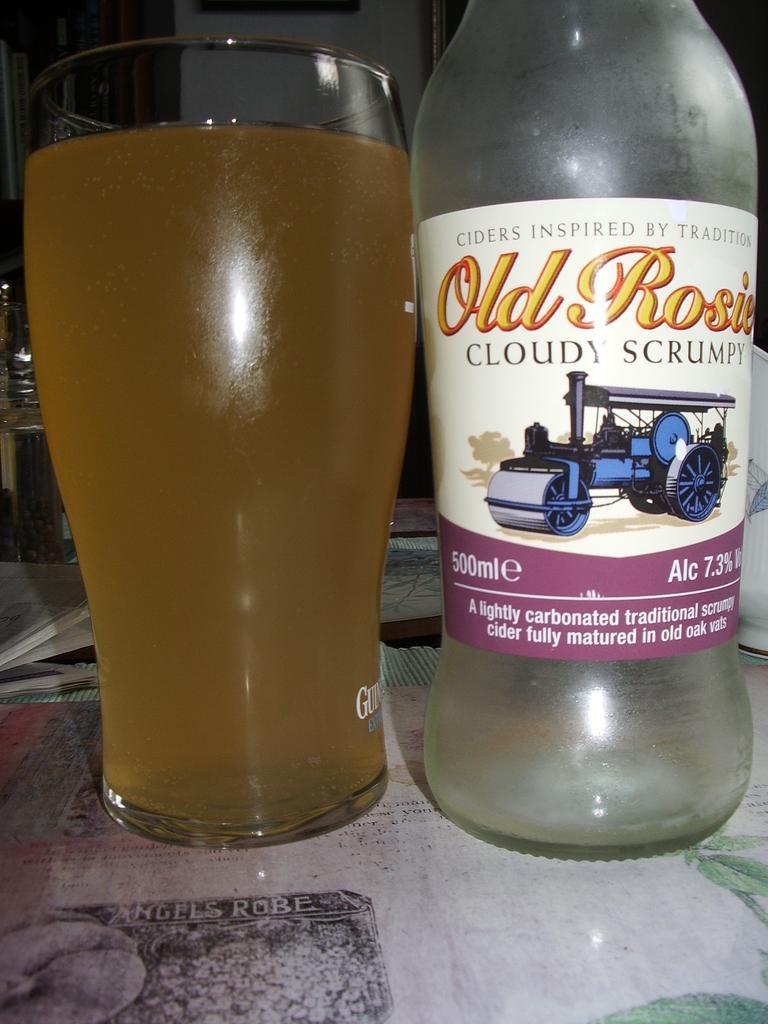Can you describe this image briefly? In this image there is a bottle which has a label as old rosie cloudy scrumpy. Beside there is a glass with a drink in it. 